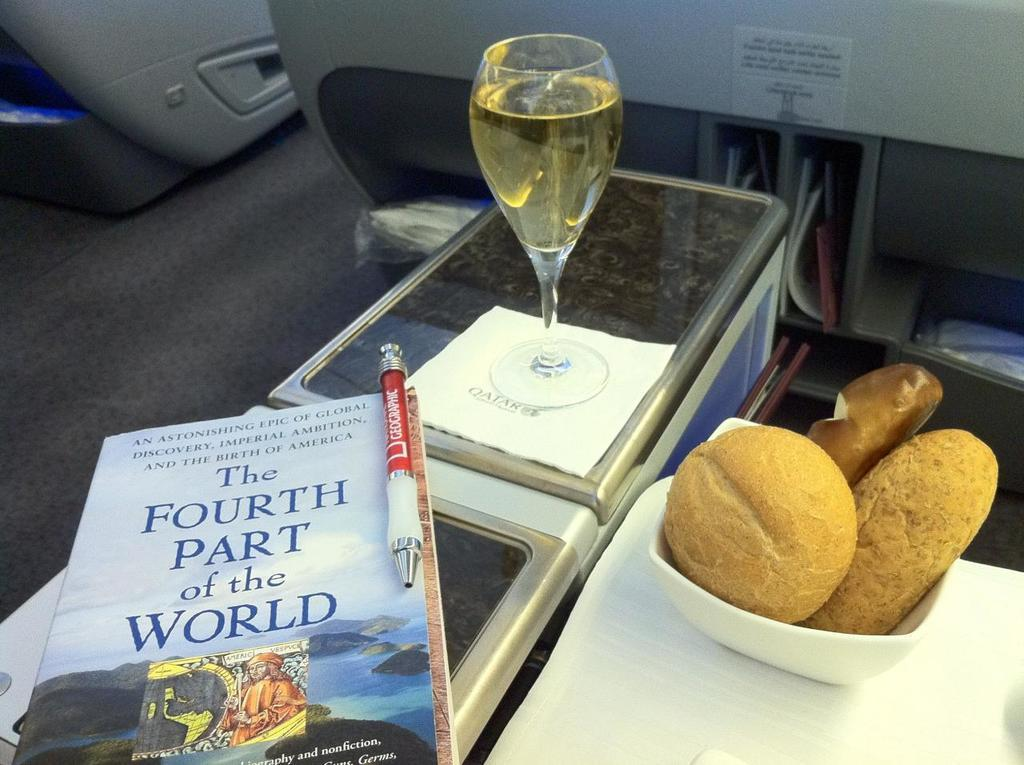<image>
Describe the image concisely. Most likely on a plane a person took a photo of there bread basket, wine and book; the book is the fourth part of the world 